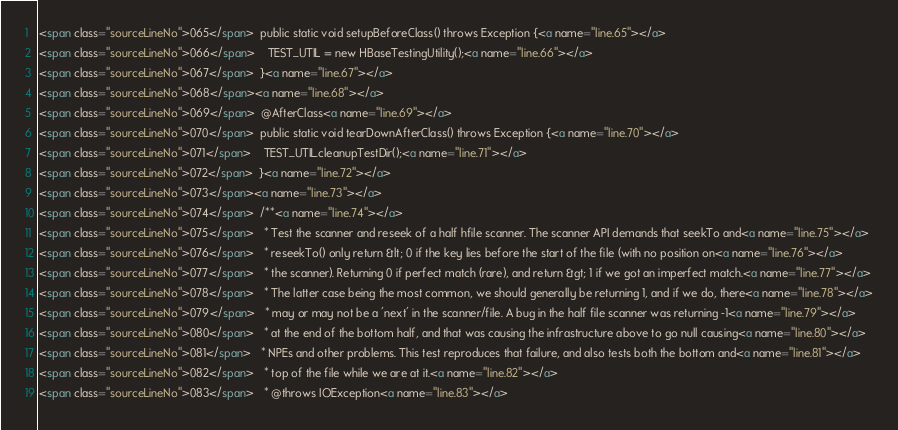Convert code to text. <code><loc_0><loc_0><loc_500><loc_500><_HTML_><span class="sourceLineNo">065</span>  public static void setupBeforeClass() throws Exception {<a name="line.65"></a>
<span class="sourceLineNo">066</span>    TEST_UTIL = new HBaseTestingUtility();<a name="line.66"></a>
<span class="sourceLineNo">067</span>  }<a name="line.67"></a>
<span class="sourceLineNo">068</span><a name="line.68"></a>
<span class="sourceLineNo">069</span>  @AfterClass<a name="line.69"></a>
<span class="sourceLineNo">070</span>  public static void tearDownAfterClass() throws Exception {<a name="line.70"></a>
<span class="sourceLineNo">071</span>    TEST_UTIL.cleanupTestDir();<a name="line.71"></a>
<span class="sourceLineNo">072</span>  }<a name="line.72"></a>
<span class="sourceLineNo">073</span><a name="line.73"></a>
<span class="sourceLineNo">074</span>  /**<a name="line.74"></a>
<span class="sourceLineNo">075</span>   * Test the scanner and reseek of a half hfile scanner. The scanner API demands that seekTo and<a name="line.75"></a>
<span class="sourceLineNo">076</span>   * reseekTo() only return &lt; 0 if the key lies before the start of the file (with no position on<a name="line.76"></a>
<span class="sourceLineNo">077</span>   * the scanner). Returning 0 if perfect match (rare), and return &gt; 1 if we got an imperfect match.<a name="line.77"></a>
<span class="sourceLineNo">078</span>   * The latter case being the most common, we should generally be returning 1, and if we do, there<a name="line.78"></a>
<span class="sourceLineNo">079</span>   * may or may not be a 'next' in the scanner/file. A bug in the half file scanner was returning -1<a name="line.79"></a>
<span class="sourceLineNo">080</span>   * at the end of the bottom half, and that was causing the infrastructure above to go null causing<a name="line.80"></a>
<span class="sourceLineNo">081</span>   * NPEs and other problems. This test reproduces that failure, and also tests both the bottom and<a name="line.81"></a>
<span class="sourceLineNo">082</span>   * top of the file while we are at it.<a name="line.82"></a>
<span class="sourceLineNo">083</span>   * @throws IOException<a name="line.83"></a></code> 